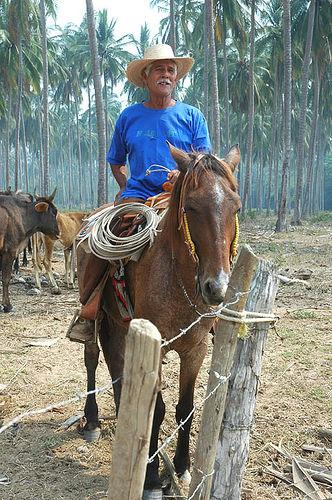Who has more white hairs, the man or his horse?
Short answer required. Man. Is this man angry?
Be succinct. No. What color is the man's shirt who is on the horse?
Answer briefly. Blue. 